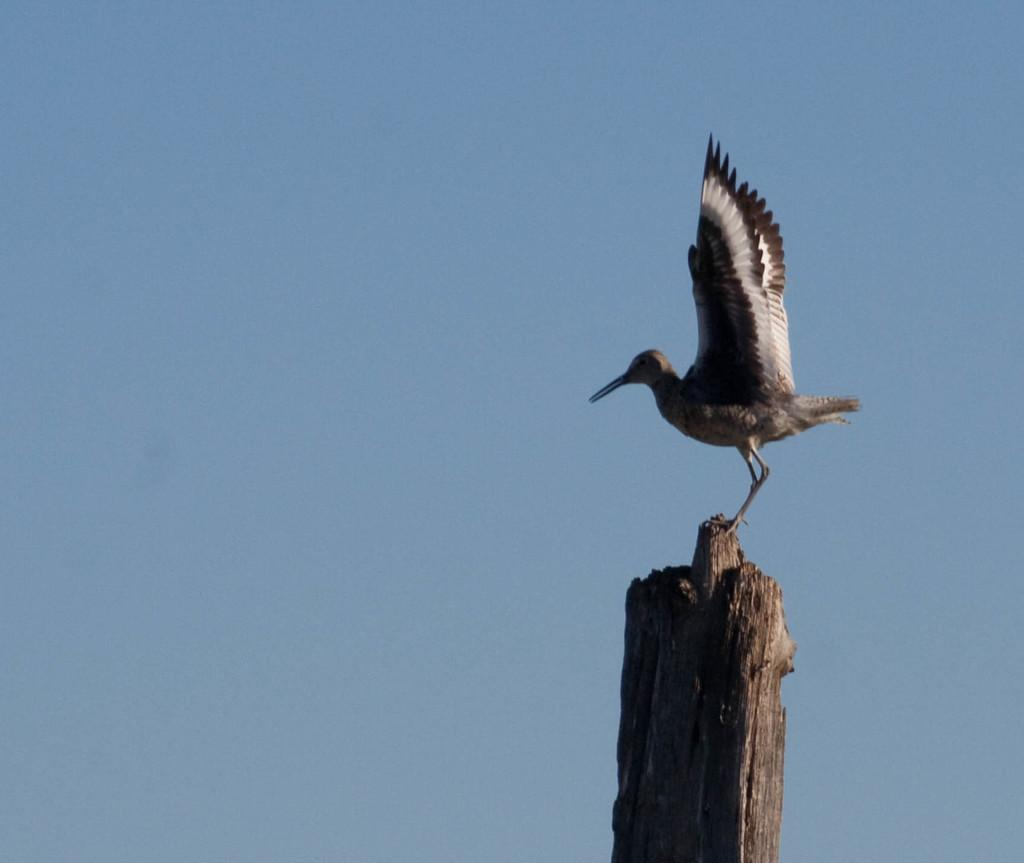What type of animal is present in the image? There is a bird in the image. What is the bird standing on in the image? The bird is standing on a wooden object. What part of the natural environment is visible in the image? The sky is visible in the image. Where is the nut that the bird is trying to crack in the image? There is no nut present in the image. Can you see the bird's pocket in the image? Birds do not have pockets, so this question is not applicable to the image. 